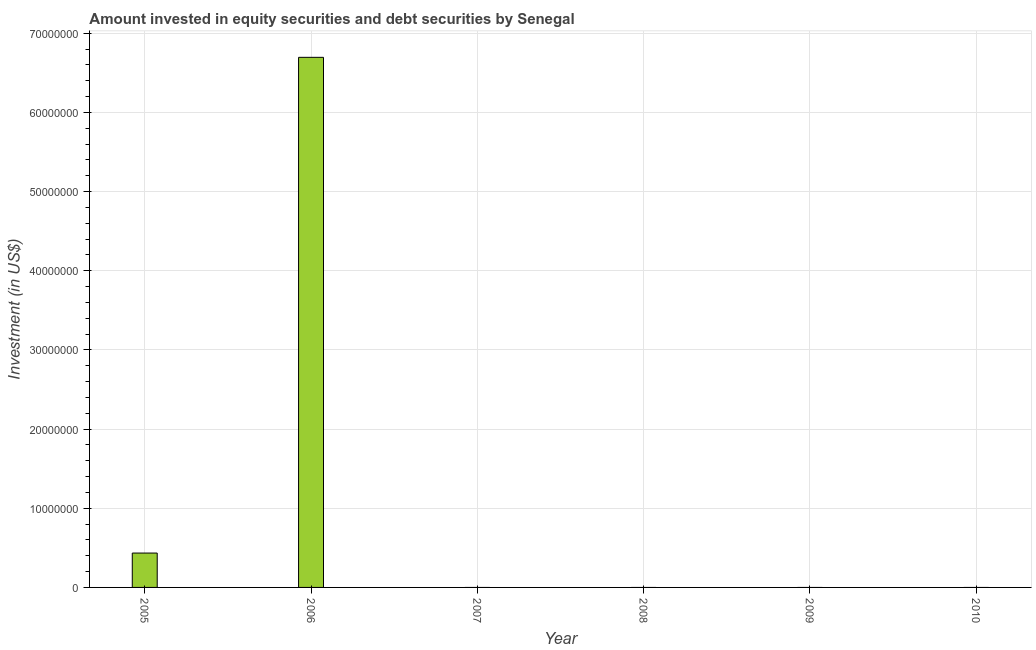What is the title of the graph?
Make the answer very short. Amount invested in equity securities and debt securities by Senegal. What is the label or title of the Y-axis?
Ensure brevity in your answer.  Investment (in US$). What is the portfolio investment in 2006?
Make the answer very short. 6.70e+07. Across all years, what is the maximum portfolio investment?
Your answer should be compact. 6.70e+07. What is the sum of the portfolio investment?
Offer a terse response. 7.13e+07. What is the average portfolio investment per year?
Your answer should be compact. 1.19e+07. In how many years, is the portfolio investment greater than 32000000 US$?
Give a very brief answer. 1. What is the difference between the highest and the lowest portfolio investment?
Offer a very short reply. 6.70e+07. How many years are there in the graph?
Provide a succinct answer. 6. What is the Investment (in US$) of 2005?
Give a very brief answer. 4.34e+06. What is the Investment (in US$) of 2006?
Give a very brief answer. 6.70e+07. What is the Investment (in US$) of 2007?
Give a very brief answer. 0. What is the Investment (in US$) in 2009?
Offer a terse response. 0. What is the Investment (in US$) in 2010?
Give a very brief answer. 0. What is the difference between the Investment (in US$) in 2005 and 2006?
Provide a short and direct response. -6.26e+07. What is the ratio of the Investment (in US$) in 2005 to that in 2006?
Offer a terse response. 0.07. 